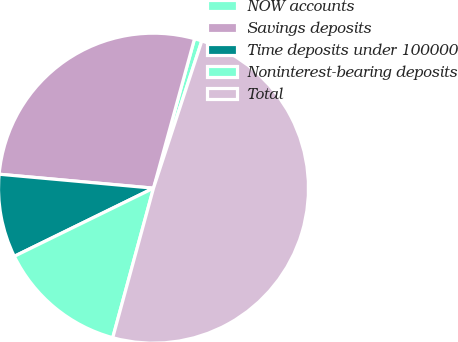Convert chart. <chart><loc_0><loc_0><loc_500><loc_500><pie_chart><fcel>NOW accounts<fcel>Savings deposits<fcel>Time deposits under 100000<fcel>Noninterest-bearing deposits<fcel>Total<nl><fcel>0.78%<fcel>27.83%<fcel>8.68%<fcel>13.52%<fcel>49.19%<nl></chart> 